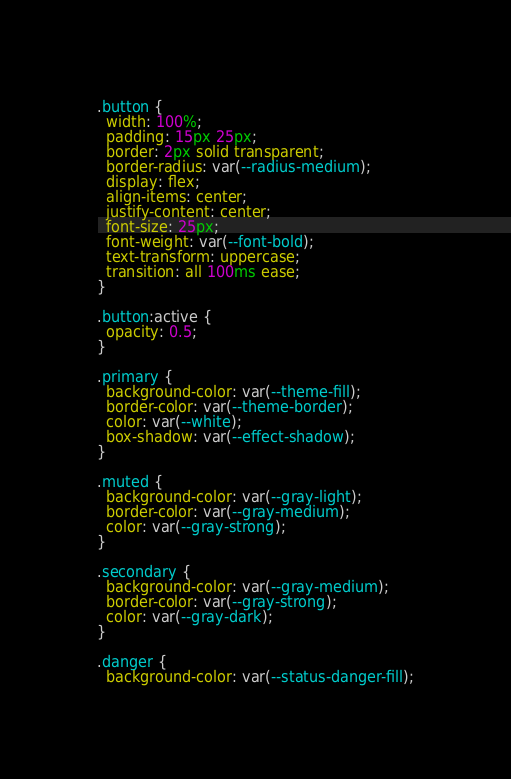<code> <loc_0><loc_0><loc_500><loc_500><_CSS_>.button {
  width: 100%;
  padding: 15px 25px;
  border: 2px solid transparent;
  border-radius: var(--radius-medium);
  display: flex;
  align-items: center;
  justify-content: center;
  font-size: 25px;
  font-weight: var(--font-bold);
  text-transform: uppercase;
  transition: all 100ms ease;
}

.button:active {
  opacity: 0.5;
}

.primary {
  background-color: var(--theme-fill);
  border-color: var(--theme-border);
  color: var(--white);
  box-shadow: var(--effect-shadow);
}

.muted {
  background-color: var(--gray-light);
  border-color: var(--gray-medium);
  color: var(--gray-strong);
}

.secondary {
  background-color: var(--gray-medium);
  border-color: var(--gray-strong);
  color: var(--gray-dark);
}

.danger {
  background-color: var(--status-danger-fill);</code> 